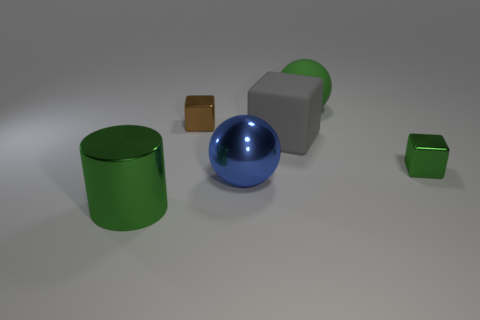Subtract all metallic blocks. How many blocks are left? 1 Add 2 tiny brown shiny cubes. How many objects exist? 8 Subtract all brown blocks. How many blocks are left? 2 Subtract all cylinders. How many objects are left? 5 Subtract all yellow cylinders. Subtract all gray cubes. How many cylinders are left? 1 Subtract all red cylinders. How many blue balls are left? 1 Subtract all green shiny things. Subtract all gray matte things. How many objects are left? 3 Add 4 large rubber objects. How many large rubber objects are left? 6 Add 3 small green metal blocks. How many small green metal blocks exist? 4 Subtract 1 green spheres. How many objects are left? 5 